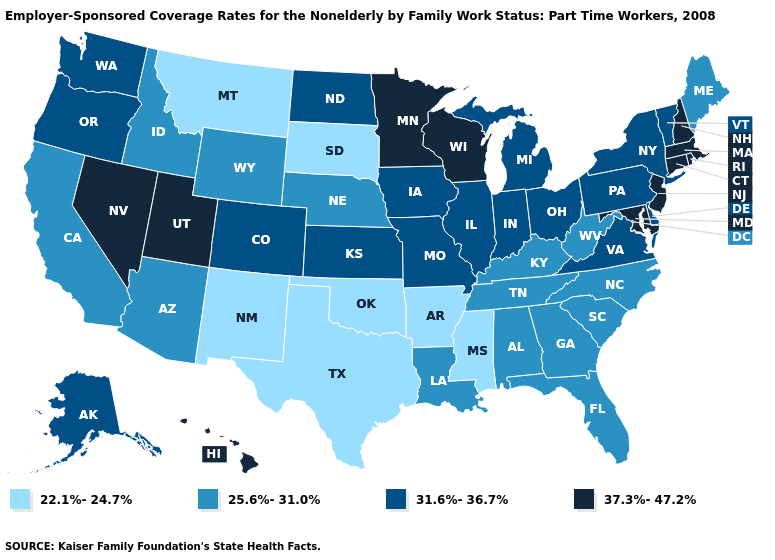How many symbols are there in the legend?
Short answer required. 4. What is the value of Alaska?
Answer briefly. 31.6%-36.7%. Which states have the lowest value in the USA?
Concise answer only. Arkansas, Mississippi, Montana, New Mexico, Oklahoma, South Dakota, Texas. Does Oklahoma have the lowest value in the USA?
Short answer required. Yes. What is the lowest value in states that border Texas?
Concise answer only. 22.1%-24.7%. Does New Mexico have the highest value in the USA?
Write a very short answer. No. What is the value of Ohio?
Give a very brief answer. 31.6%-36.7%. Among the states that border Washington , which have the highest value?
Give a very brief answer. Oregon. Name the states that have a value in the range 31.6%-36.7%?
Concise answer only. Alaska, Colorado, Delaware, Illinois, Indiana, Iowa, Kansas, Michigan, Missouri, New York, North Dakota, Ohio, Oregon, Pennsylvania, Vermont, Virginia, Washington. Name the states that have a value in the range 37.3%-47.2%?
Quick response, please. Connecticut, Hawaii, Maryland, Massachusetts, Minnesota, Nevada, New Hampshire, New Jersey, Rhode Island, Utah, Wisconsin. What is the value of Wisconsin?
Keep it brief. 37.3%-47.2%. Is the legend a continuous bar?
Keep it brief. No. Does the first symbol in the legend represent the smallest category?
Concise answer only. Yes. Which states have the lowest value in the USA?
Keep it brief. Arkansas, Mississippi, Montana, New Mexico, Oklahoma, South Dakota, Texas. Among the states that border Texas , which have the highest value?
Answer briefly. Louisiana. 